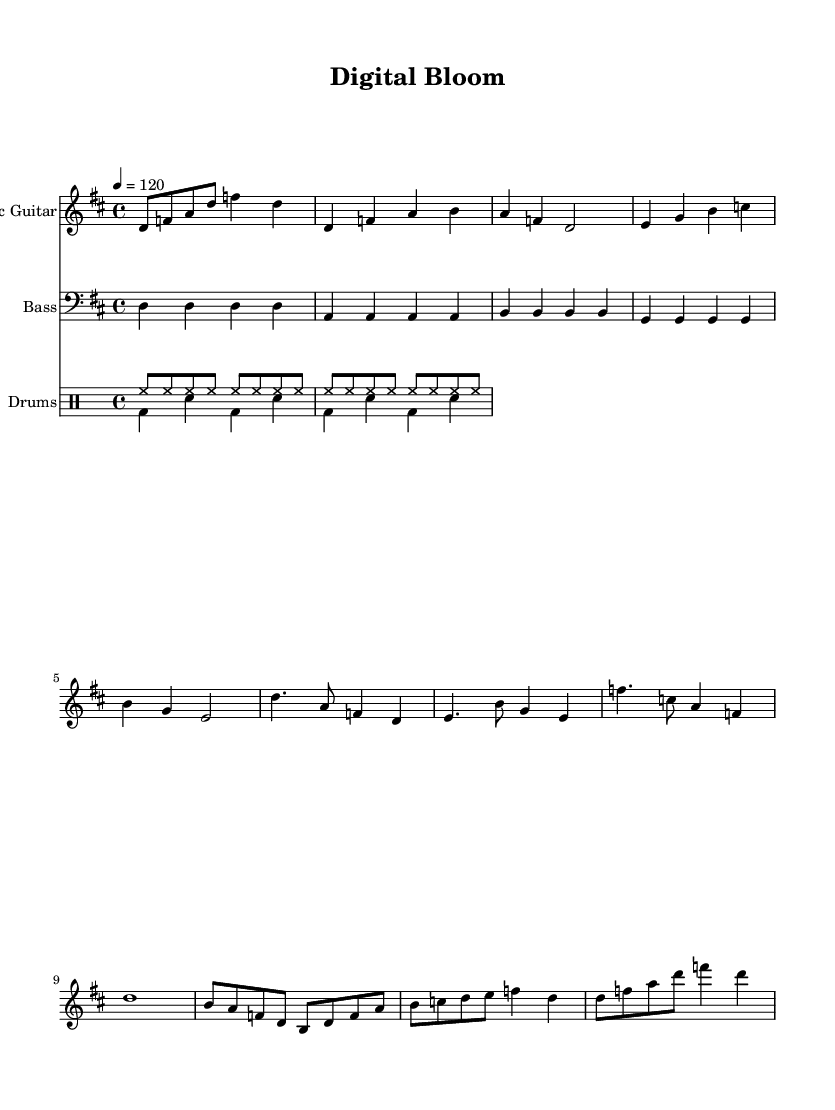What is the key signature of this music? The key signature is D major, which contains two sharps: F# and C#. This is typically indicated at the beginning of the staff and aligns with the notes throughout the piece.
Answer: D major What is the time signature of this music? The time signature is 4/4, indicating there are four beats in each measure and the quarter note gets one beat. This is essential for understanding the rhythmic structure of the piece.
Answer: 4/4 What is the tempo marking of this music? The tempo marking is 120 beats per minute, which indicates how fast the piece should be played. It is usually written near the beginning and helps set the mood for the performance.
Answer: 120 How many measures are in the verse section? The verse section contains four measures, which can be counted by locating the bar lines and identifying how many groups of four beats exist within the section marked as the verse.
Answer: 4 Which instrument plays the main melodic line in this piece? The main melodic line is played by the Electric Guitar, as indicated at the start of the staff for that instrument and through the presence of the treble clef that typically denotes melody.
Answer: Electric Guitar What lyrical theme is presented in the chorus? The lyrical theme in the chorus revolves around the idea of growth and intertwining of organic and technological elements, which is evident from the phrasing in the words provided beneath the melody in the score.
Answer: Growth and intertwining How does the bass line relate to the guitar part? The bass line directly supports the harmony by following a simple root progression that aligns with the chords played in the guitar part, creating a foundation for the overall sound of the song.
Answer: Supports harmony 